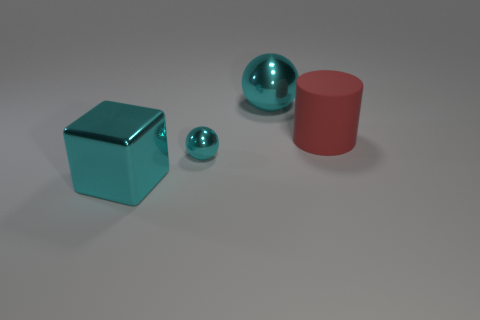Add 3 large shiny cubes. How many objects exist? 7 Subtract all cylinders. How many objects are left? 3 Add 2 large cyan metal things. How many large cyan metal things are left? 4 Add 2 big red cylinders. How many big red cylinders exist? 3 Subtract 0 gray blocks. How many objects are left? 4 Subtract all gray cubes. Subtract all brown cylinders. How many cubes are left? 1 Subtract all blocks. Subtract all blocks. How many objects are left? 2 